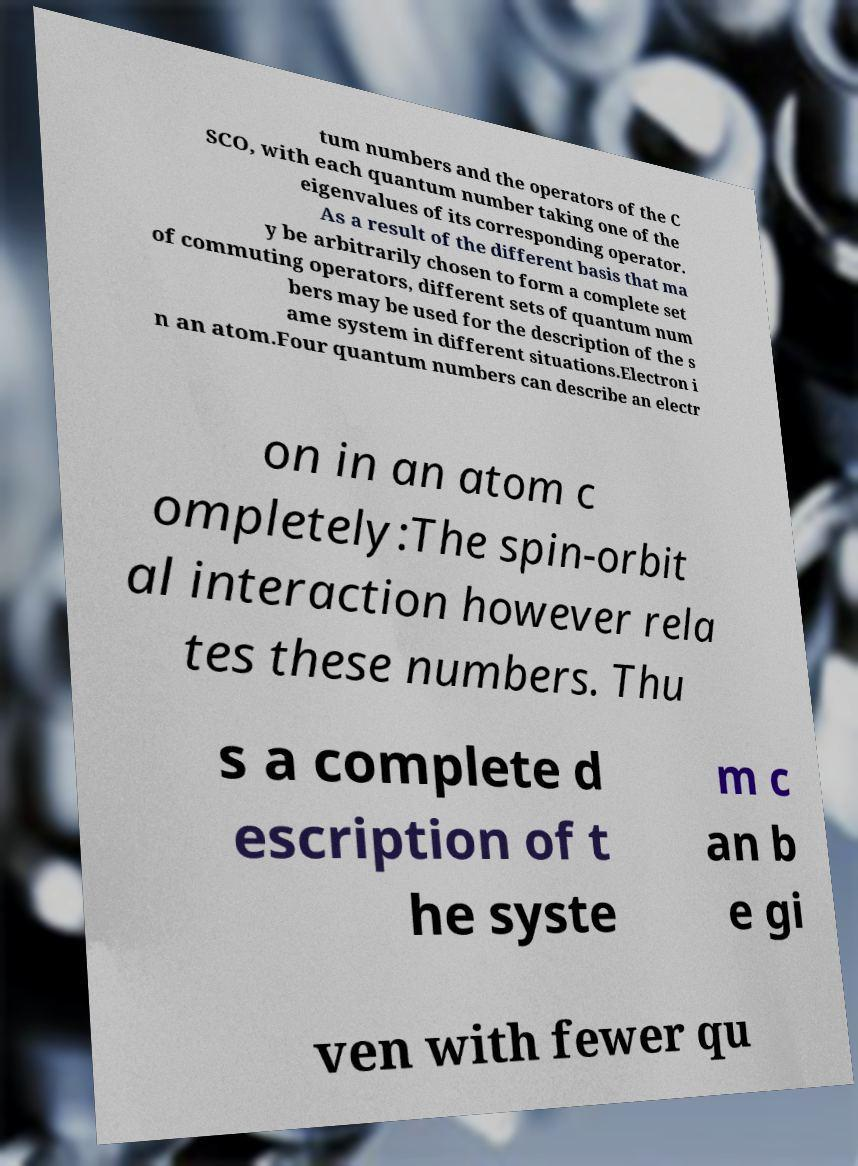Could you extract and type out the text from this image? tum numbers and the operators of the C SCO, with each quantum number taking one of the eigenvalues of its corresponding operator. As a result of the different basis that ma y be arbitrarily chosen to form a complete set of commuting operators, different sets of quantum num bers may be used for the description of the s ame system in different situations.Electron i n an atom.Four quantum numbers can describe an electr on in an atom c ompletely:The spin-orbit al interaction however rela tes these numbers. Thu s a complete d escription of t he syste m c an b e gi ven with fewer qu 